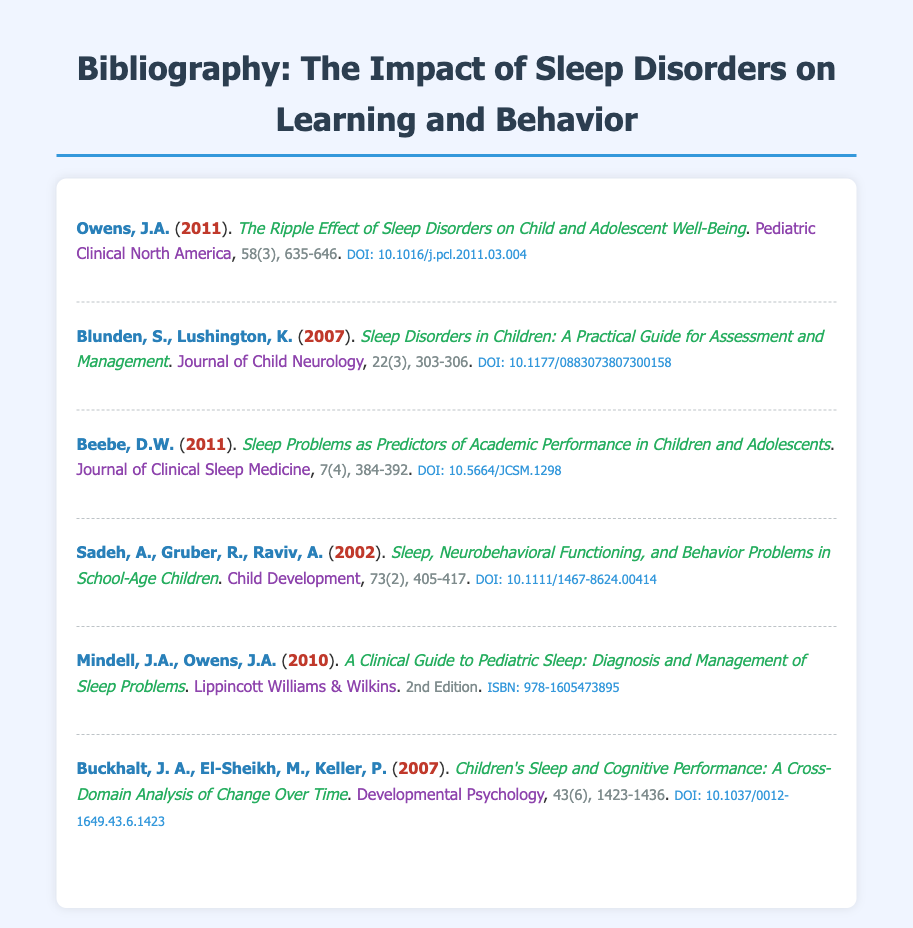What is the title of Owens' 2011 article? The title of the article by Owens is listed in the document as "The Ripple Effect of Sleep Disorders on Child and Adolescent Well-Being."
Answer: The Ripple Effect of Sleep Disorders on Child and Adolescent Well-Being Who are the authors of the article published in the Journal of Child Neurology in 2007? The authors of the article are Blunden and Lushington.
Answer: Blunden, S., Lushington, K What is the publication year of the article "Sleep Problems as Predictors of Academic Performance in Children and Adolescents"? The publication year is indicated in the document next to the title of Beebe's article.
Answer: 2011 In which journal was the article "Sleep, Neurobehavioral Functioning, and Behavior Problems in School-Age Children" published? The journal name is provided directly in the entry for Sadeh et al.’s article.
Answer: Child Development What is the ISBN of the book "A Clinical Guide to Pediatric Sleep"? The ISBN is clearly stated in the entry for Mindell and Owens’ book.
Answer: 978-1605473895 How many articles are listed in the bibliography? The total count of entries in the bibliography indicates the number of articles.
Answer: 6 Which publication type is included only for the fifth entry? The fifth entry has a publisher listed, which is unique compared to the others that are journal articles.
Answer: Publisher 